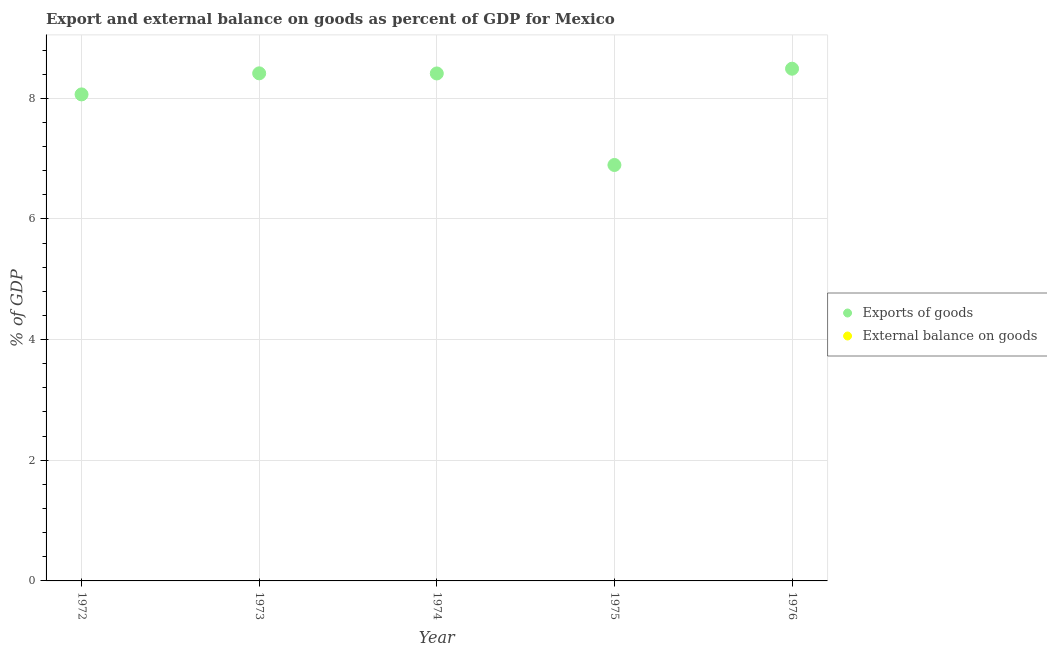Is the number of dotlines equal to the number of legend labels?
Ensure brevity in your answer.  No. What is the export of goods as percentage of gdp in 1975?
Give a very brief answer. 6.89. Across all years, what is the maximum export of goods as percentage of gdp?
Offer a very short reply. 8.49. Across all years, what is the minimum external balance on goods as percentage of gdp?
Keep it short and to the point. 0. In which year was the export of goods as percentage of gdp maximum?
Your answer should be very brief. 1976. What is the total export of goods as percentage of gdp in the graph?
Offer a terse response. 40.27. What is the difference between the export of goods as percentage of gdp in 1974 and that in 1975?
Offer a terse response. 1.52. What is the difference between the external balance on goods as percentage of gdp in 1975 and the export of goods as percentage of gdp in 1973?
Make the answer very short. -8.41. What is the average export of goods as percentage of gdp per year?
Give a very brief answer. 8.05. What is the ratio of the export of goods as percentage of gdp in 1973 to that in 1975?
Make the answer very short. 1.22. What is the difference between the highest and the second highest export of goods as percentage of gdp?
Your answer should be compact. 0.08. What is the difference between the highest and the lowest export of goods as percentage of gdp?
Offer a very short reply. 1.6. In how many years, is the external balance on goods as percentage of gdp greater than the average external balance on goods as percentage of gdp taken over all years?
Keep it short and to the point. 0. Is the sum of the export of goods as percentage of gdp in 1972 and 1975 greater than the maximum external balance on goods as percentage of gdp across all years?
Your response must be concise. Yes. Does the external balance on goods as percentage of gdp monotonically increase over the years?
Your answer should be very brief. No. Is the export of goods as percentage of gdp strictly less than the external balance on goods as percentage of gdp over the years?
Provide a short and direct response. No. How many dotlines are there?
Offer a very short reply. 1. Are the values on the major ticks of Y-axis written in scientific E-notation?
Give a very brief answer. No. Does the graph contain grids?
Your answer should be compact. Yes. How are the legend labels stacked?
Provide a succinct answer. Vertical. What is the title of the graph?
Your answer should be very brief. Export and external balance on goods as percent of GDP for Mexico. Does "Male entrants" appear as one of the legend labels in the graph?
Your response must be concise. No. What is the label or title of the Y-axis?
Keep it short and to the point. % of GDP. What is the % of GDP of Exports of goods in 1972?
Your answer should be very brief. 8.06. What is the % of GDP of Exports of goods in 1973?
Provide a short and direct response. 8.41. What is the % of GDP in External balance on goods in 1973?
Ensure brevity in your answer.  0. What is the % of GDP in Exports of goods in 1974?
Your response must be concise. 8.41. What is the % of GDP in Exports of goods in 1975?
Offer a terse response. 6.89. What is the % of GDP in Exports of goods in 1976?
Ensure brevity in your answer.  8.49. Across all years, what is the maximum % of GDP in Exports of goods?
Give a very brief answer. 8.49. Across all years, what is the minimum % of GDP in Exports of goods?
Your response must be concise. 6.89. What is the total % of GDP in Exports of goods in the graph?
Your response must be concise. 40.27. What is the total % of GDP of External balance on goods in the graph?
Keep it short and to the point. 0. What is the difference between the % of GDP of Exports of goods in 1972 and that in 1973?
Your response must be concise. -0.35. What is the difference between the % of GDP in Exports of goods in 1972 and that in 1974?
Keep it short and to the point. -0.35. What is the difference between the % of GDP in Exports of goods in 1972 and that in 1975?
Keep it short and to the point. 1.17. What is the difference between the % of GDP of Exports of goods in 1972 and that in 1976?
Keep it short and to the point. -0.43. What is the difference between the % of GDP of Exports of goods in 1973 and that in 1974?
Provide a short and direct response. 0. What is the difference between the % of GDP in Exports of goods in 1973 and that in 1975?
Offer a terse response. 1.52. What is the difference between the % of GDP in Exports of goods in 1973 and that in 1976?
Provide a short and direct response. -0.08. What is the difference between the % of GDP in Exports of goods in 1974 and that in 1975?
Your answer should be very brief. 1.52. What is the difference between the % of GDP in Exports of goods in 1974 and that in 1976?
Provide a short and direct response. -0.08. What is the difference between the % of GDP of Exports of goods in 1975 and that in 1976?
Provide a succinct answer. -1.6. What is the average % of GDP in Exports of goods per year?
Provide a succinct answer. 8.05. What is the ratio of the % of GDP in Exports of goods in 1972 to that in 1973?
Offer a terse response. 0.96. What is the ratio of the % of GDP in Exports of goods in 1972 to that in 1974?
Ensure brevity in your answer.  0.96. What is the ratio of the % of GDP in Exports of goods in 1972 to that in 1975?
Provide a succinct answer. 1.17. What is the ratio of the % of GDP in Exports of goods in 1972 to that in 1976?
Give a very brief answer. 0.95. What is the ratio of the % of GDP in Exports of goods in 1973 to that in 1975?
Provide a short and direct response. 1.22. What is the ratio of the % of GDP of Exports of goods in 1974 to that in 1975?
Give a very brief answer. 1.22. What is the ratio of the % of GDP in Exports of goods in 1974 to that in 1976?
Offer a very short reply. 0.99. What is the ratio of the % of GDP in Exports of goods in 1975 to that in 1976?
Your answer should be compact. 0.81. What is the difference between the highest and the second highest % of GDP of Exports of goods?
Provide a succinct answer. 0.08. What is the difference between the highest and the lowest % of GDP of Exports of goods?
Provide a succinct answer. 1.6. 